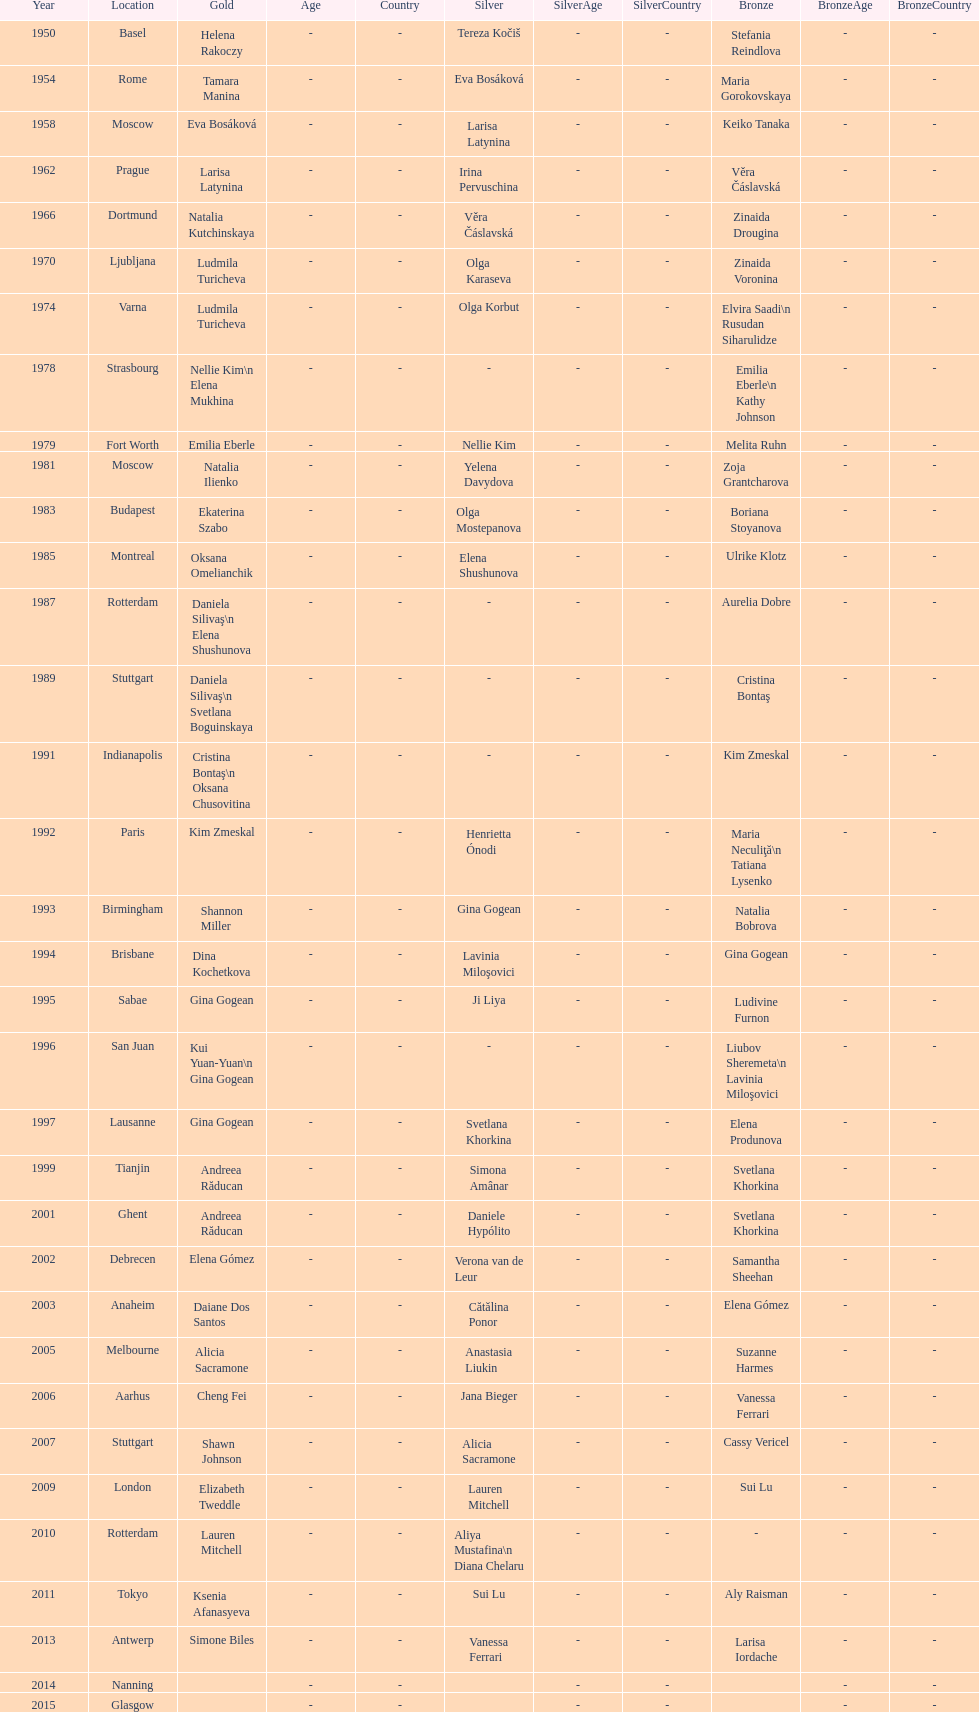Which two american rivals won consecutive floor exercise gold medals at the artistic gymnastics world championships in 1992 and 1993? Kim Zmeskal, Shannon Miller. 